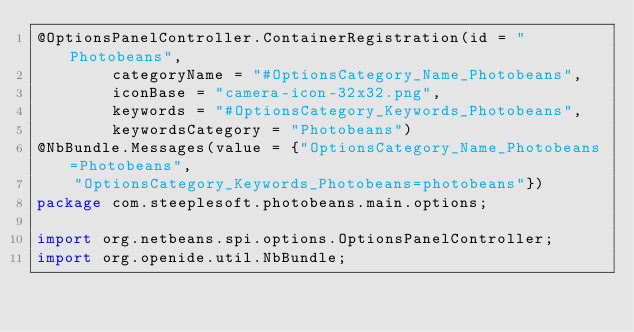Convert code to text. <code><loc_0><loc_0><loc_500><loc_500><_Java_>@OptionsPanelController.ContainerRegistration(id = "Photobeans", 
        categoryName = "#OptionsCategory_Name_Photobeans", 
        iconBase = "camera-icon-32x32.png", 
        keywords = "#OptionsCategory_Keywords_Photobeans", 
        keywordsCategory = "Photobeans")
@NbBundle.Messages(value = {"OptionsCategory_Name_Photobeans=Photobeans", 
    "OptionsCategory_Keywords_Photobeans=photobeans"})
package com.steeplesoft.photobeans.main.options;

import org.netbeans.spi.options.OptionsPanelController;
import org.openide.util.NbBundle;
</code> 